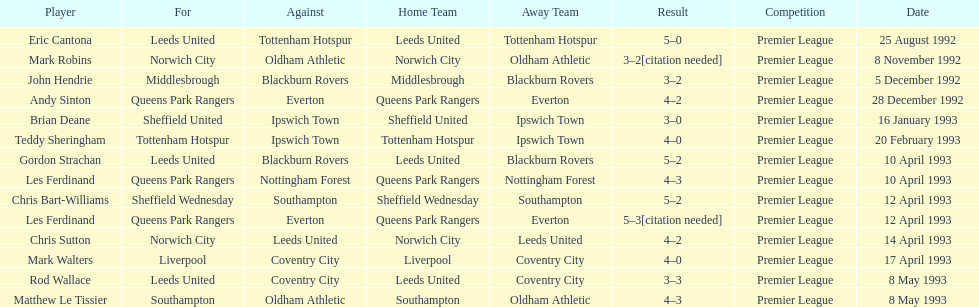Name the players for tottenham hotspur. Teddy Sheringham. 